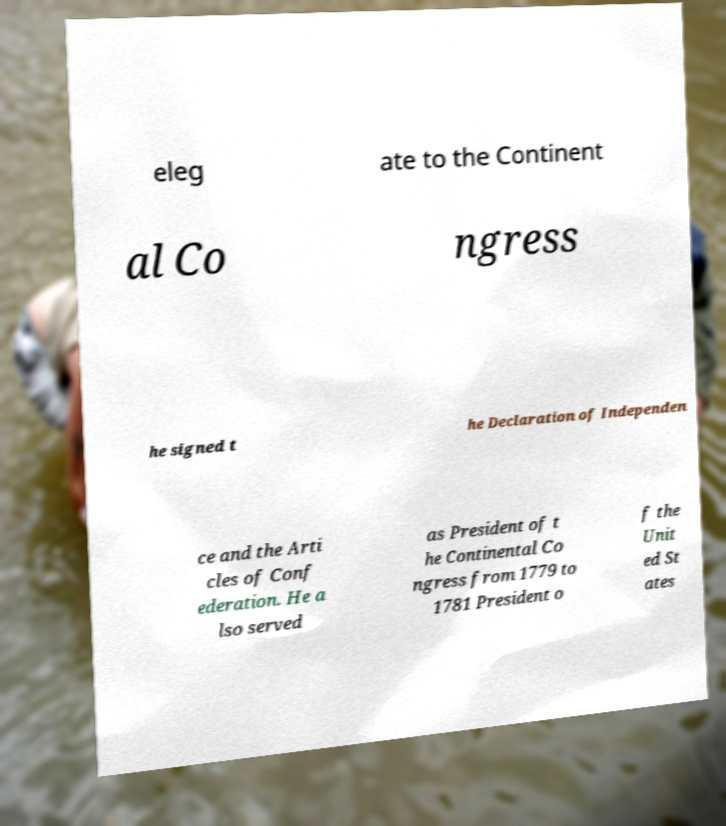Please read and relay the text visible in this image. What does it say? eleg ate to the Continent al Co ngress he signed t he Declaration of Independen ce and the Arti cles of Conf ederation. He a lso served as President of t he Continental Co ngress from 1779 to 1781 President o f the Unit ed St ates 